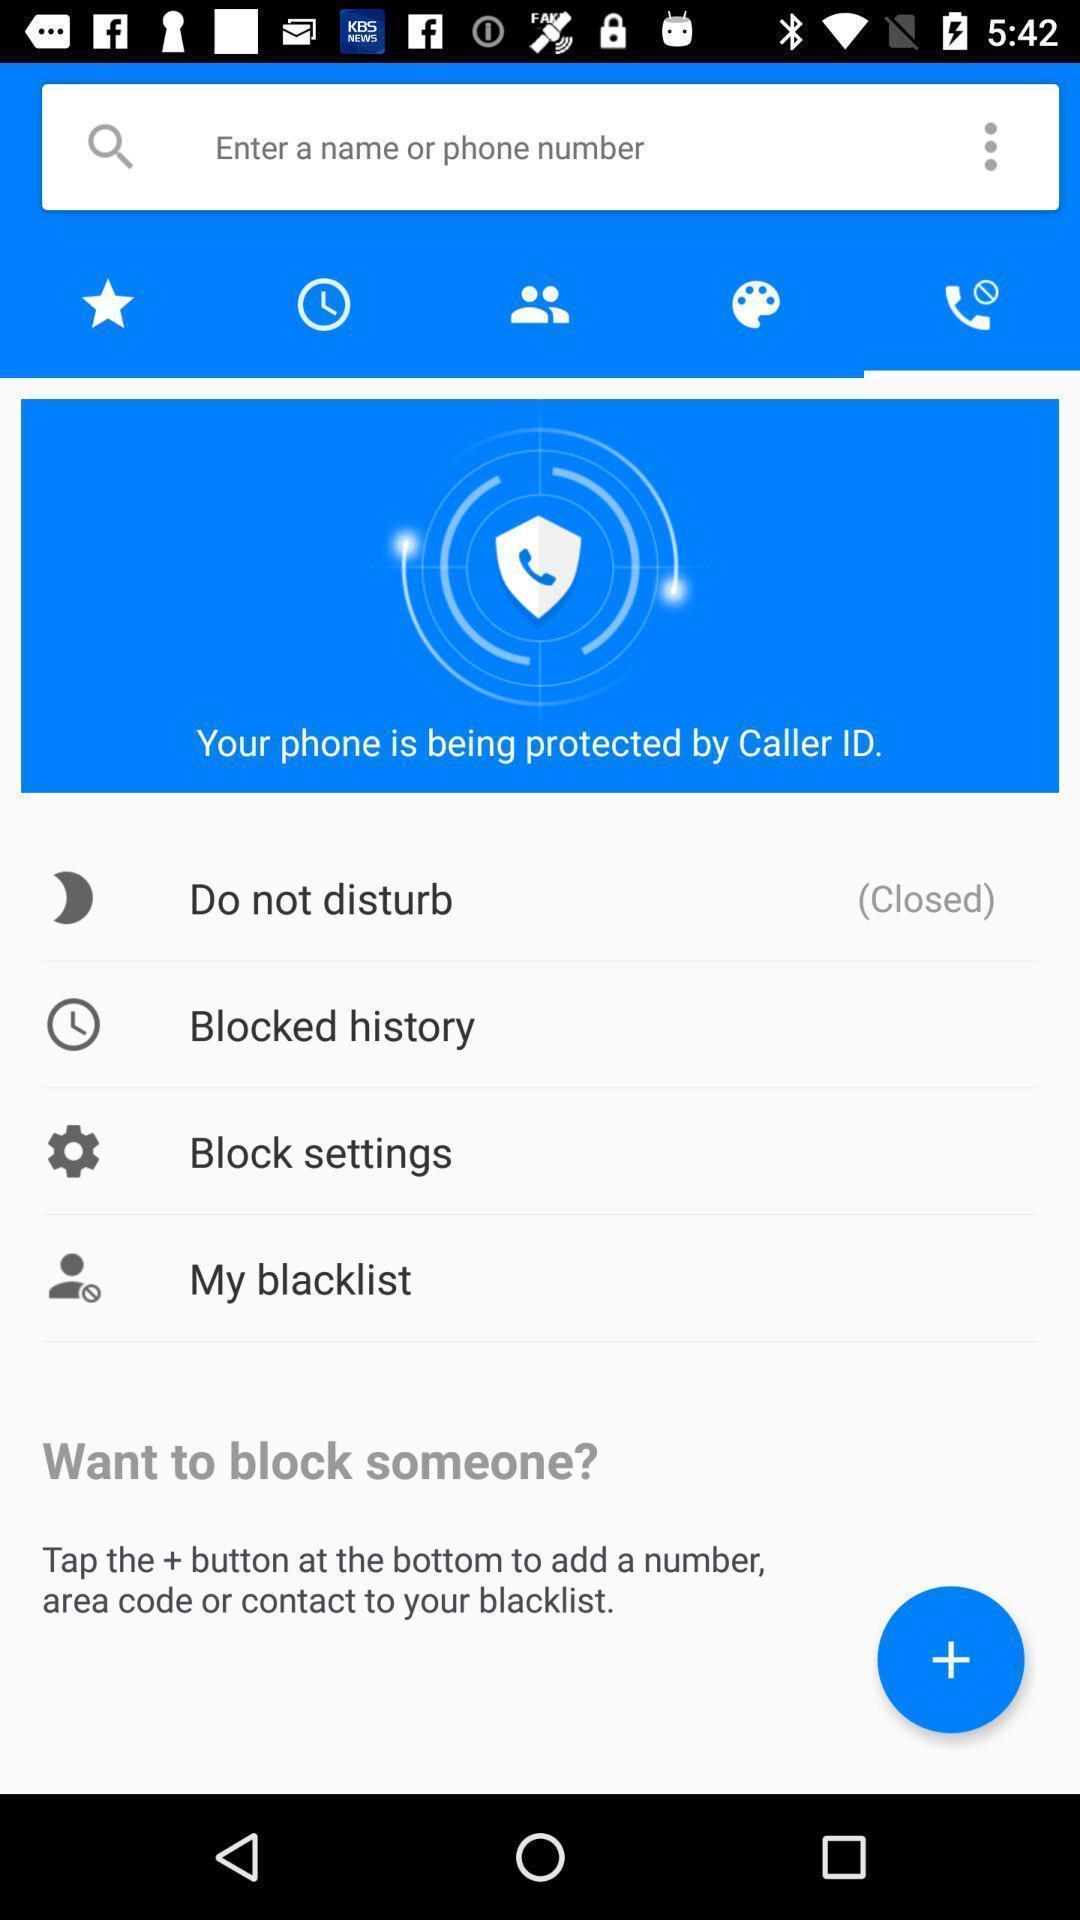Summarize the information in this screenshot. Screen display multiple call options like blocked history. 